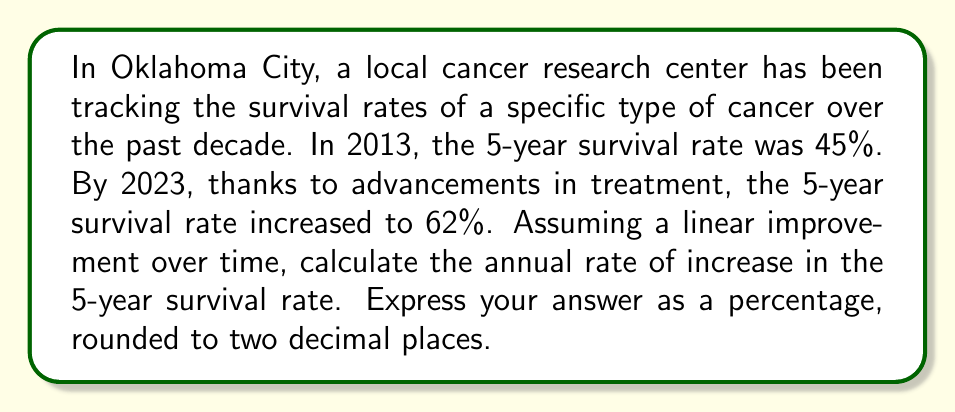What is the answer to this math problem? To solve this problem, we'll follow these steps:

1. Identify the given information:
   - Initial year: 2013
   - Final year: 2023
   - Initial survival rate: 45%
   - Final survival rate: 62%
   - Time period: 10 years (2023 - 2013 = 10)

2. Calculate the total increase in survival rate:
   $\text{Total increase} = 62\% - 45\% = 17\%$

3. Calculate the annual rate of increase:
   $$\text{Annual rate} = \frac{\text{Total increase}}{\text{Number of years}}$$
   $$\text{Annual rate} = \frac{17\%}{10 \text{ years}}$$
   $$\text{Annual rate} = 1.7\% \text{ per year}$$

4. Round the result to two decimal places:
   1.7% is already rounded to two decimal places, so no further rounding is necessary.

This linear model assumes that the survival rate increased by the same amount each year over the 10-year period.
Answer: 1.70% per year 